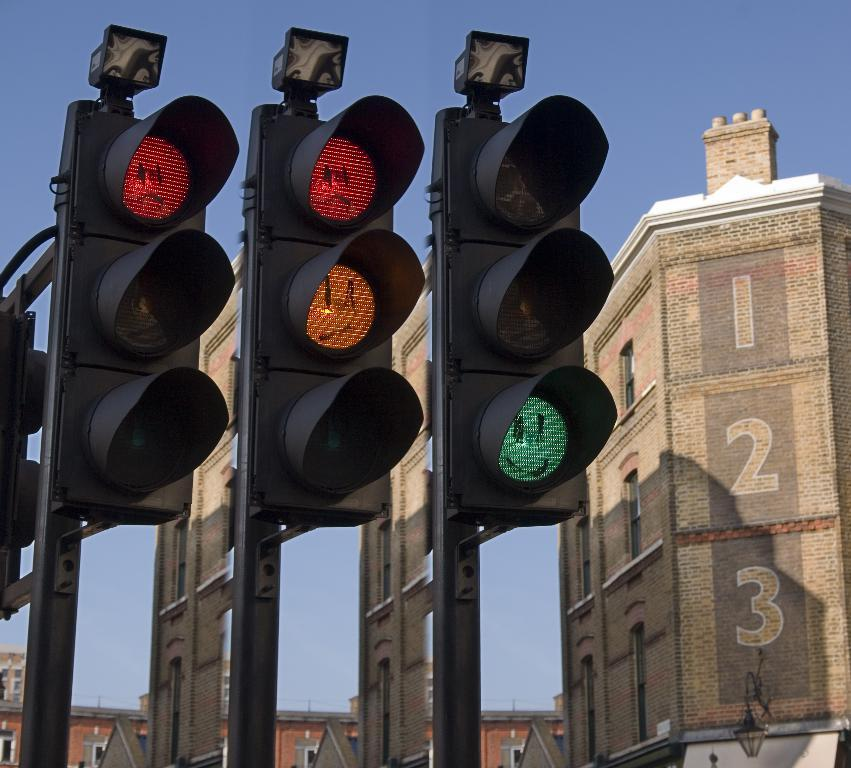<image>
Give a short and clear explanation of the subsequent image. Traffic lights with smiley faces drawn over them next to a building with the numbers 1, 2 and 3 printed on them. 